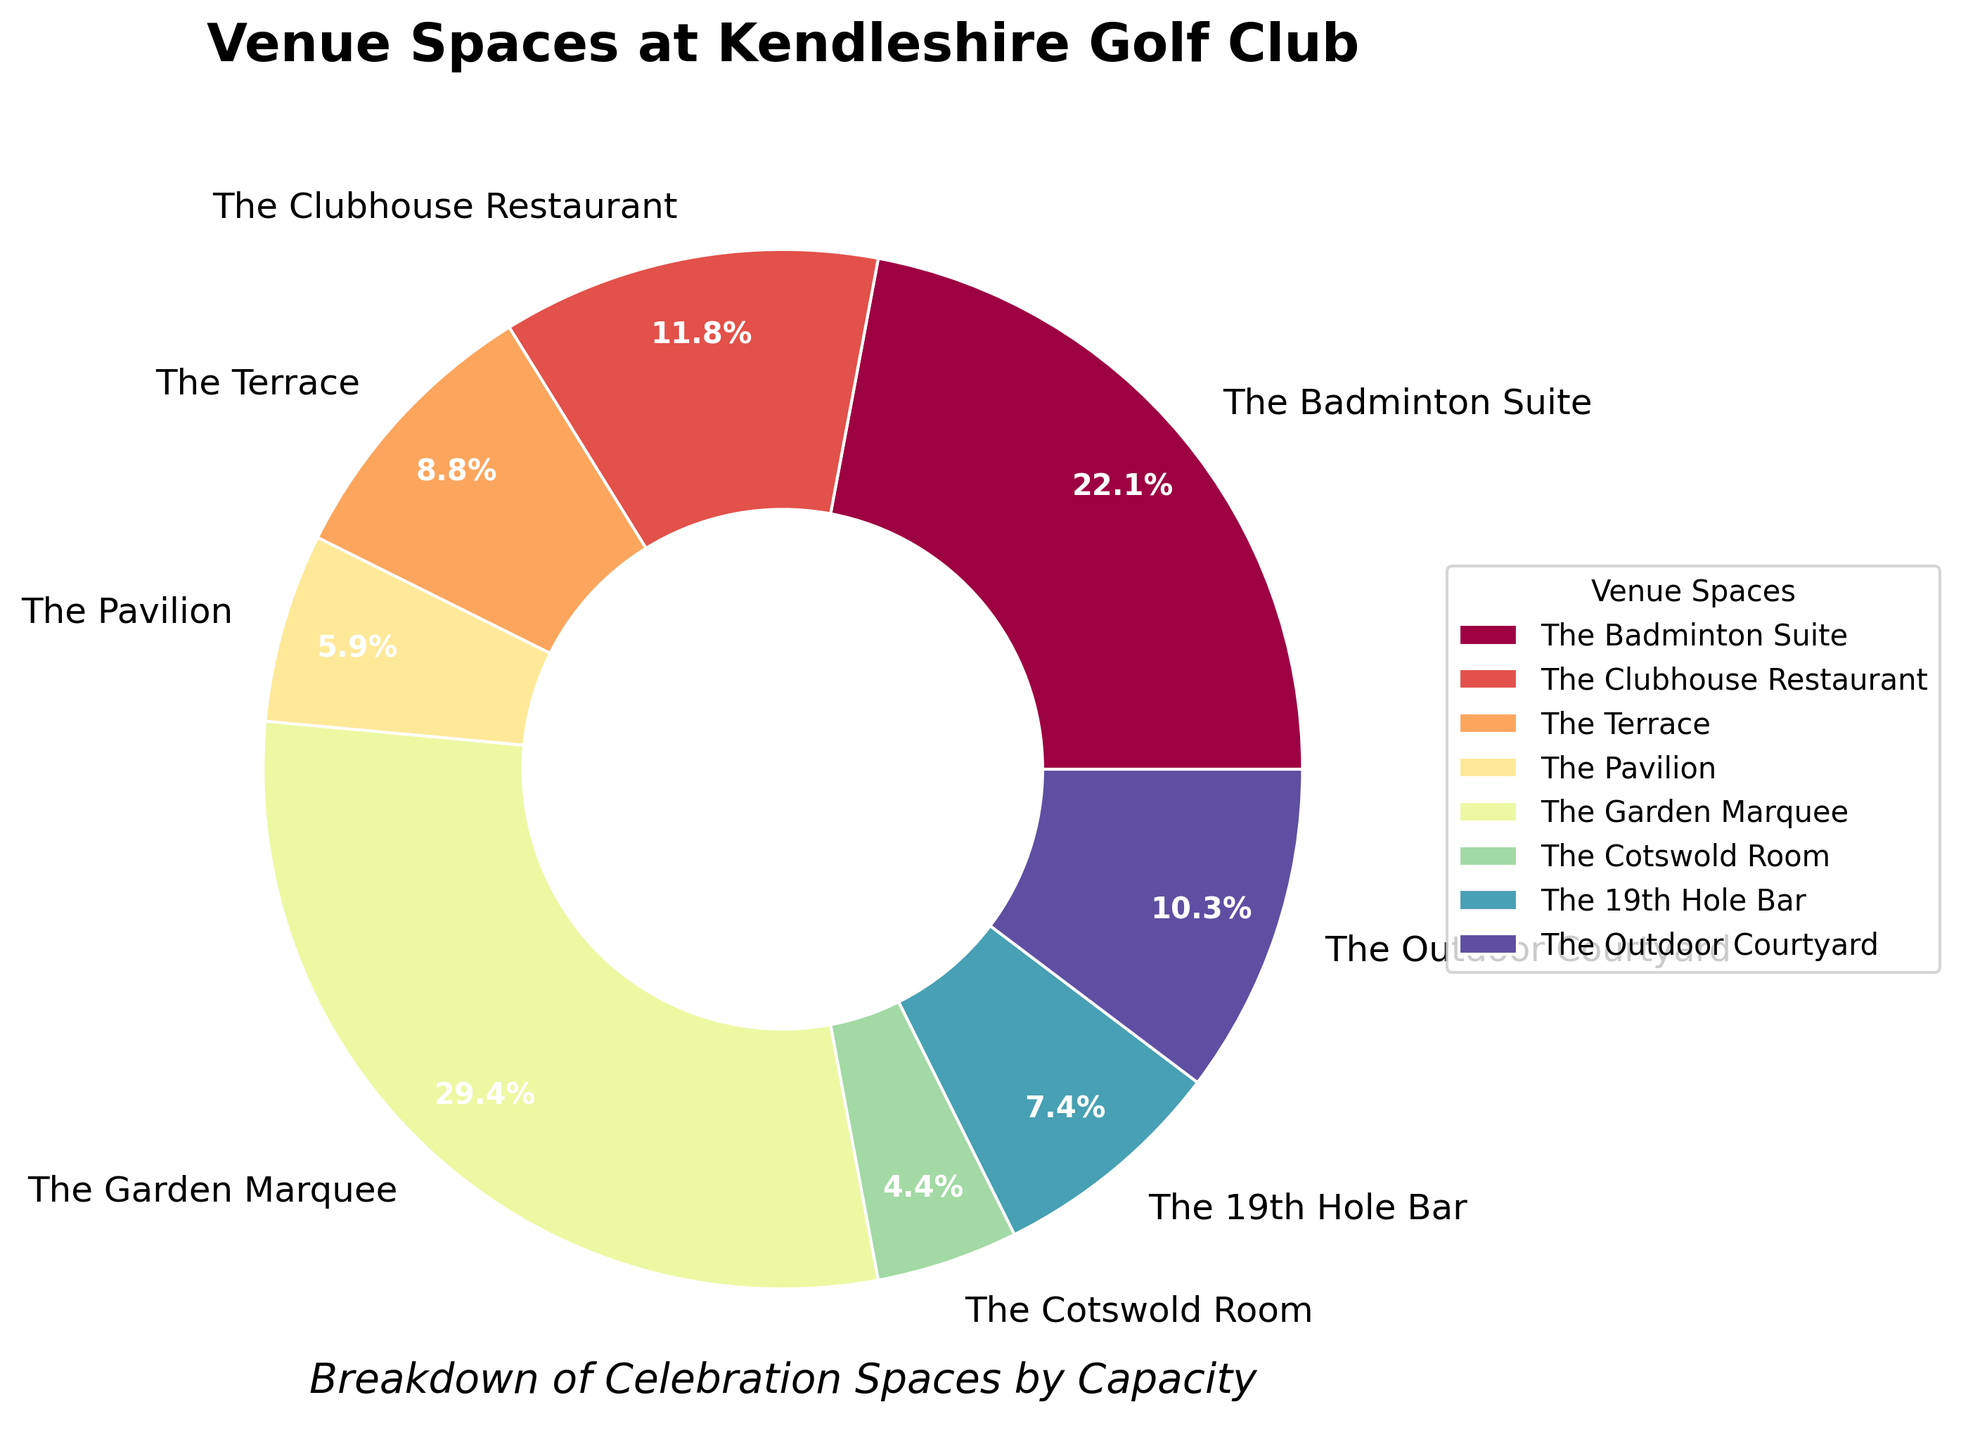What is the venue space with the highest capacity? Observing the wedges' sizes and the percentage labels, the "Garden Marquee" has the largest wedge, indicating it has the highest capacity.
Answer: The Garden Marquee Which two venue spaces have the smallest capacities? By looking at the smallest wedges and the percentage labels, the "Cotswold Room" and the "Pavilion" have the smallest capacities.
Answer: The Cotswold Room and The Pavilion What is the total capacity of all venue spaces? Sum the capacities of all venue spaces: 150 + 80 + 60 + 40 + 200 + 30 + 50 + 70 = 680.
Answer: 680 Which venue space has a greater capacity, The Terrace or The 19th Hole Bar? Compare the sizes of the wedges for "The Terrace" and "The 19th Hole Bar"; the label shows "The Terrace" has 60 and "The 19th Hole Bar" has 50.
Answer: The Terrace How much larger is the capacity of The Clubhouse Restaurant compared to The Pavilion? Subtract the capacity of "The Pavilion" (40) from "The Clubhouse Restaurant" (80); 80 - 40 = 40.
Answer: 40 Which two venue spaces combined have the same capacity as the Garden Marquee? The capacity of "The Garden Marquee" is 200. Combining "The Badminton Suite" (150) and "The Cotswold Room" (30) plus "The 19th Hole Bar" (50) results in the sum of 200.
Answer: The Badminton Suite and The 19th Hole Bar What percentage of the total capacity is the Outdoor Courtyard? Divide the capacity of the "Outdoor Courtyard" (70) by the total capacity (680) and multiply by 100: (70/680) * 100 ≈ 10.3%.
Answer: 10.3% Are there more venue spaces with a capacity of at least 100 or less than 100? By counting the venue spaces with a capacity of at least 100 (The Badminton Suite and The Garden Marquee = 2) versus those with less than 100 (The Clubhouse Restaurant, The Terrace, The Pavilion, The Cotswold Room, The 19th Hole Bar, and The Outdoor Courtyard = 6), there are more venue spaces less than 100.
Answer: Less than 100 What is the average capacity of the venue spaces? Sum the capacities (680) and divide by the number of venue spaces (8): 680/8 = 85.
Answer: 85 In terms of percentage, how much larger is the Badminton Suite compared to the Cotswold Room? Calculate the percentage difference: ((150 - 30) / 30) * 100 = 400%.
Answer: 400% 